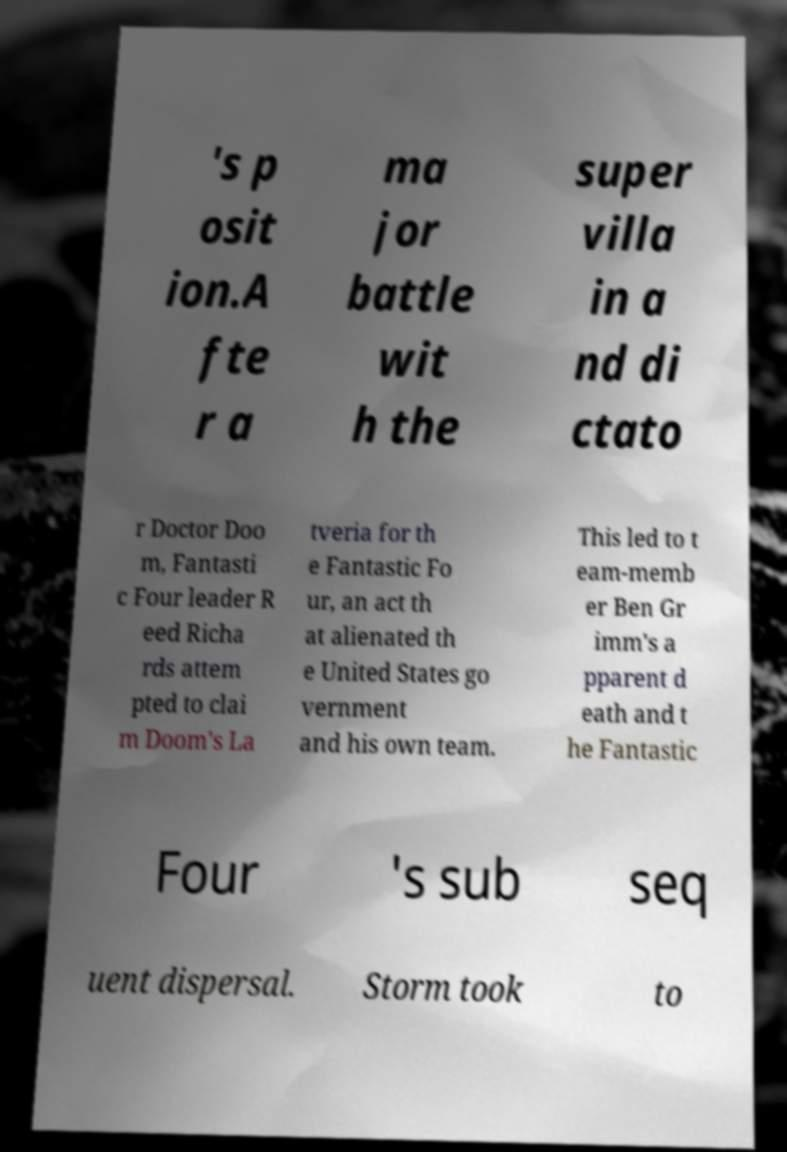There's text embedded in this image that I need extracted. Can you transcribe it verbatim? 's p osit ion.A fte r a ma jor battle wit h the super villa in a nd di ctato r Doctor Doo m, Fantasti c Four leader R eed Richa rds attem pted to clai m Doom's La tveria for th e Fantastic Fo ur, an act th at alienated th e United States go vernment and his own team. This led to t eam-memb er Ben Gr imm's a pparent d eath and t he Fantastic Four 's sub seq uent dispersal. Storm took to 